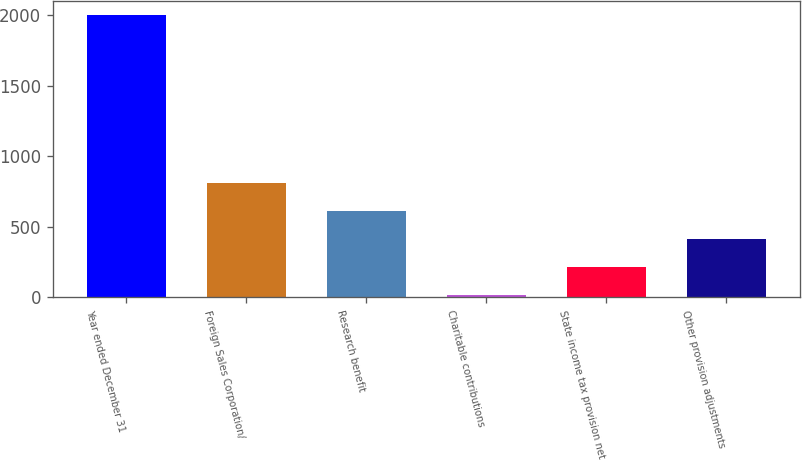Convert chart. <chart><loc_0><loc_0><loc_500><loc_500><bar_chart><fcel>Year ended December 31<fcel>Foreign Sales Corporation/<fcel>Research benefit<fcel>Charitable contributions<fcel>State income tax provision net<fcel>Other provision adjustments<nl><fcel>2003<fcel>809<fcel>610<fcel>13<fcel>212<fcel>411<nl></chart> 